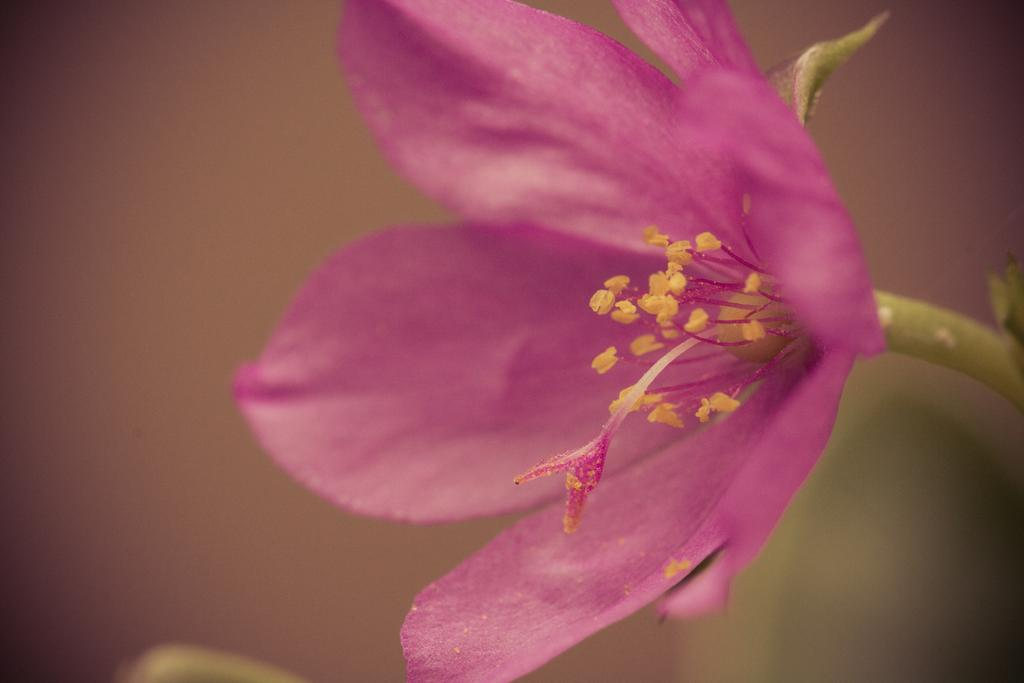What is the main subject of the image? The main subject of the image is a flow to the stem. Can you describe the flow in the image? Unfortunately, the provided facts do not give any details about the flow, so it cannot be described. How many planes are flying over the business in the image? There is no mention of planes or a business in the image, so this question cannot be answered. 